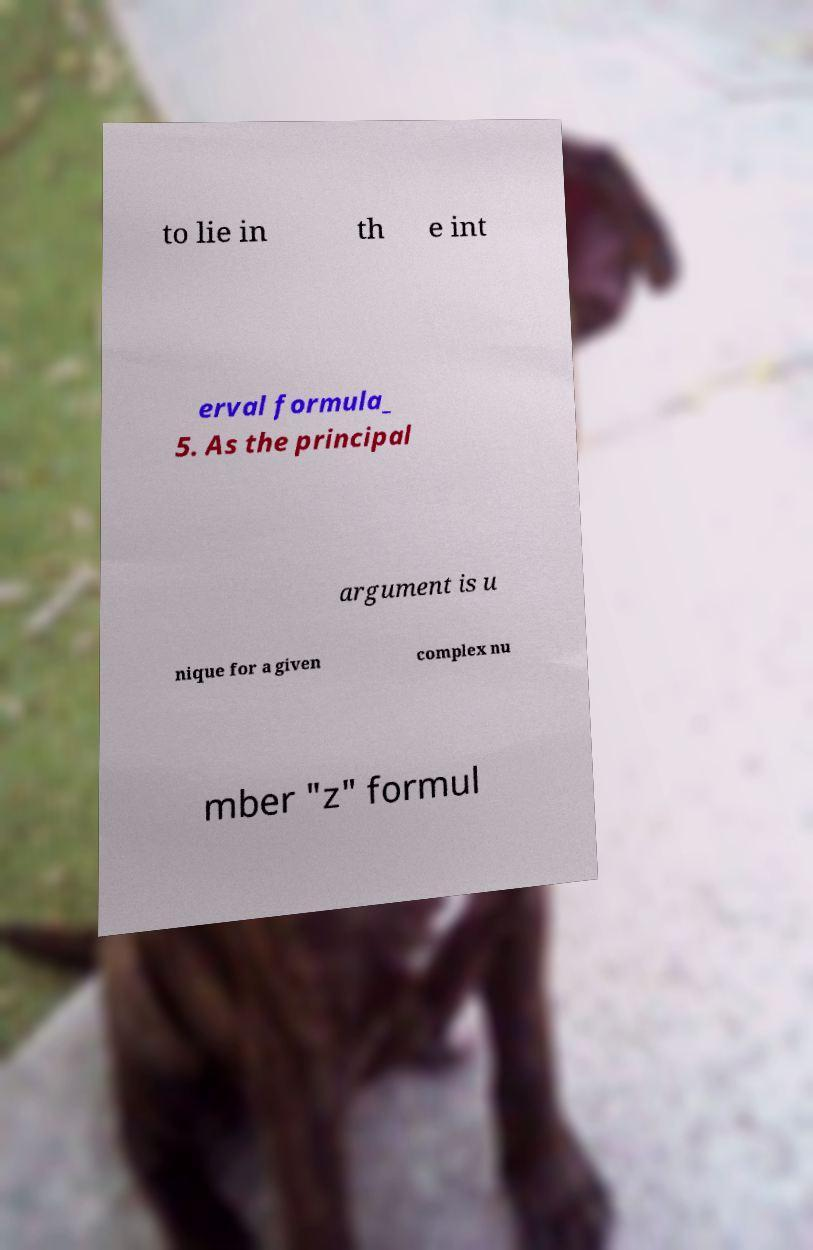There's text embedded in this image that I need extracted. Can you transcribe it verbatim? to lie in th e int erval formula_ 5. As the principal argument is u nique for a given complex nu mber "z" formul 